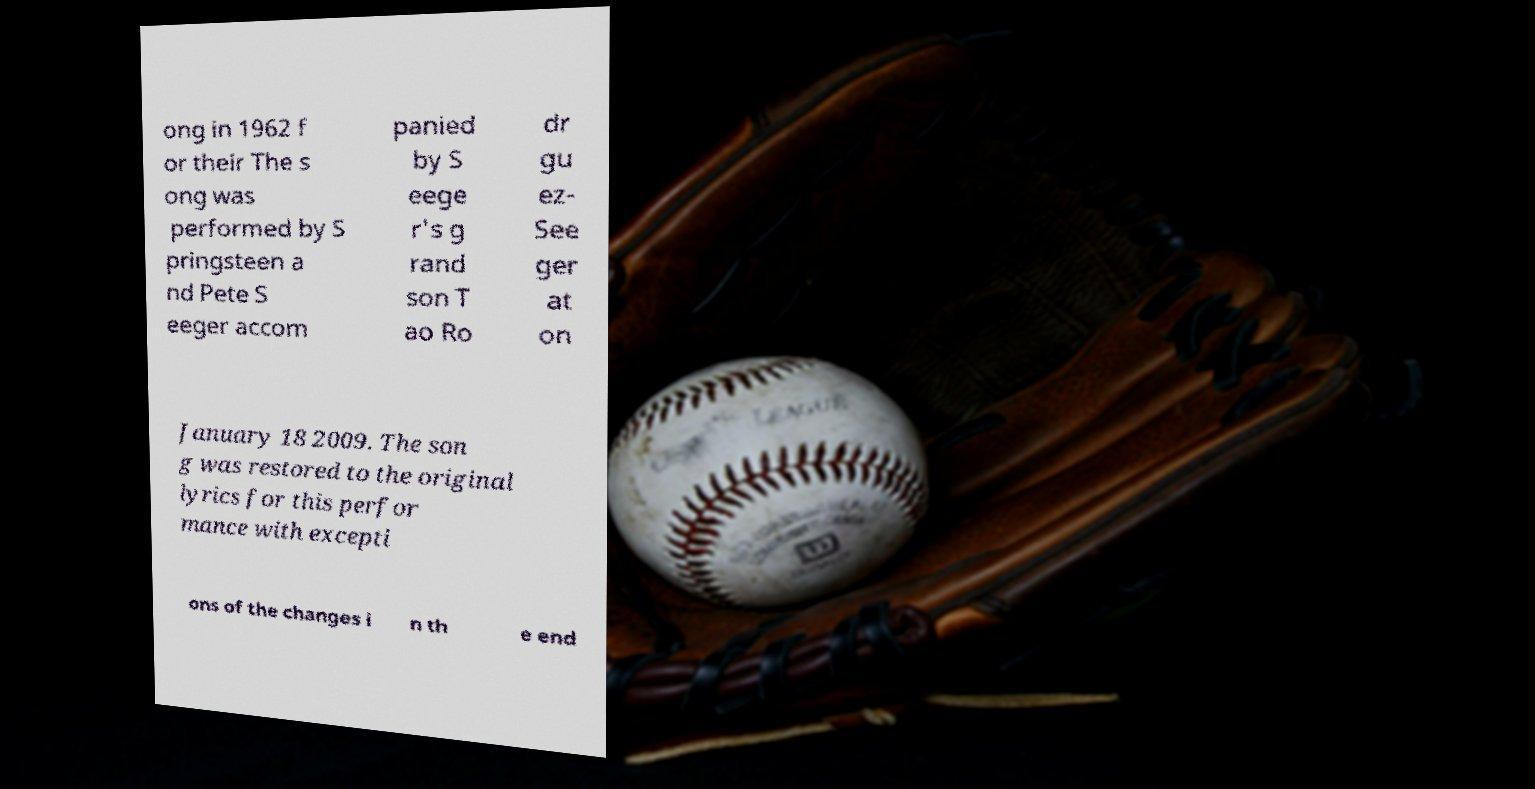For documentation purposes, I need the text within this image transcribed. Could you provide that? ong in 1962 f or their The s ong was performed by S pringsteen a nd Pete S eeger accom panied by S eege r's g rand son T ao Ro dr gu ez- See ger at on January 18 2009. The son g was restored to the original lyrics for this perfor mance with excepti ons of the changes i n th e end 